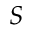<formula> <loc_0><loc_0><loc_500><loc_500>S</formula> 